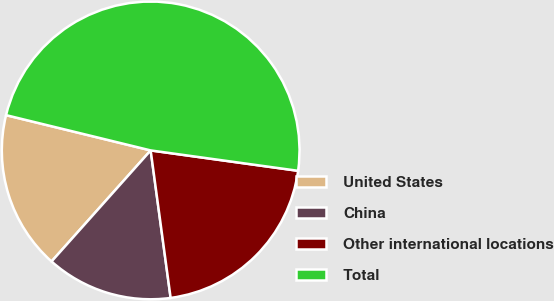<chart> <loc_0><loc_0><loc_500><loc_500><pie_chart><fcel>United States<fcel>China<fcel>Other international locations<fcel>Total<nl><fcel>17.21%<fcel>13.74%<fcel>20.67%<fcel>48.38%<nl></chart> 